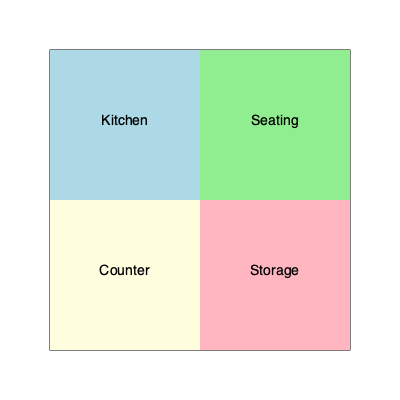Given the floor plan of your bakery/cafe shown above, which arrangement would be most efficient for customer flow and staff productivity? To determine the most efficient arrangement for customer flow and staff productivity, we need to consider several factors:

1. Kitchen placement: The kitchen should be easily accessible to both the counter and seating areas for efficient service.

2. Counter location: The counter should be near the entrance to greet customers and take orders quickly.

3. Seating area: This should be separate from the main traffic flow but still accessible.

4. Storage: Ideally, storage should be close to both the kitchen and counter for easy restocking.

Analyzing the given floor plan:

a) The kitchen is in the top-left corner, adjacent to both the seating area and counter.
b) The counter is in the bottom-left, which could be near the entrance (assuming it's on the left side).
c) The seating area is in the top-right, separated from the main operational areas.
d) Storage is in the bottom-right, accessible from both the kitchen and counter.

This arrangement allows for:
- Easy food preparation and delivery from kitchen to counter and seating area.
- Quick customer service at the counter near the entrance.
- A separate, comfortable seating area for dine-in customers.
- Convenient access to supplies for both kitchen and counter staff.

Therefore, the given arrangement is indeed the most efficient for customer flow and staff productivity.
Answer: The given arrangement 